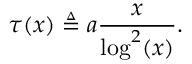Convert formula to latex. <formula><loc_0><loc_0><loc_500><loc_500>\tau ( x ) \triangle q a \frac { x } { \log ^ { 2 } ( x ) } .</formula> 